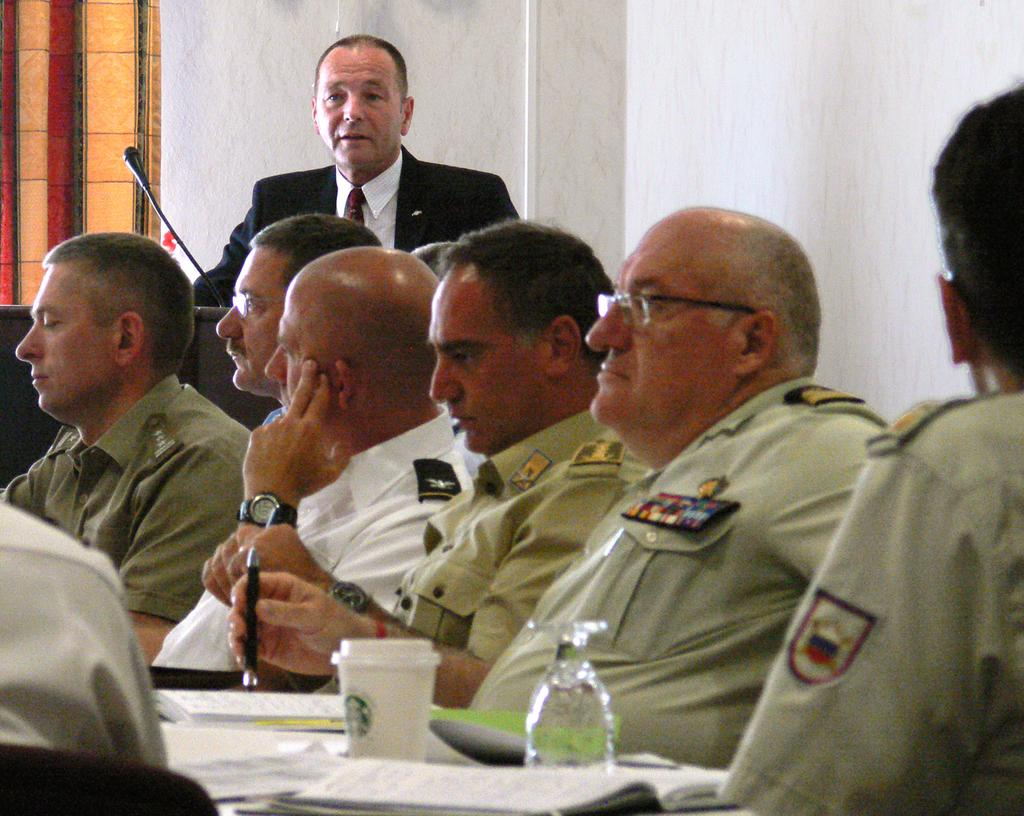What are the people in the image doing? The people in the image are sitting on chairs. What is in front of the chairs? There is a table in front of the chairs. What items can be seen on the table? There are books and bottles on the table. What can be seen in the background of the image? In the background, there is a man standing in front of a podium. What type of locket is hanging from the man's neck in the image? There is no locket visible in the image; the man is standing in front of a podium in the background. 